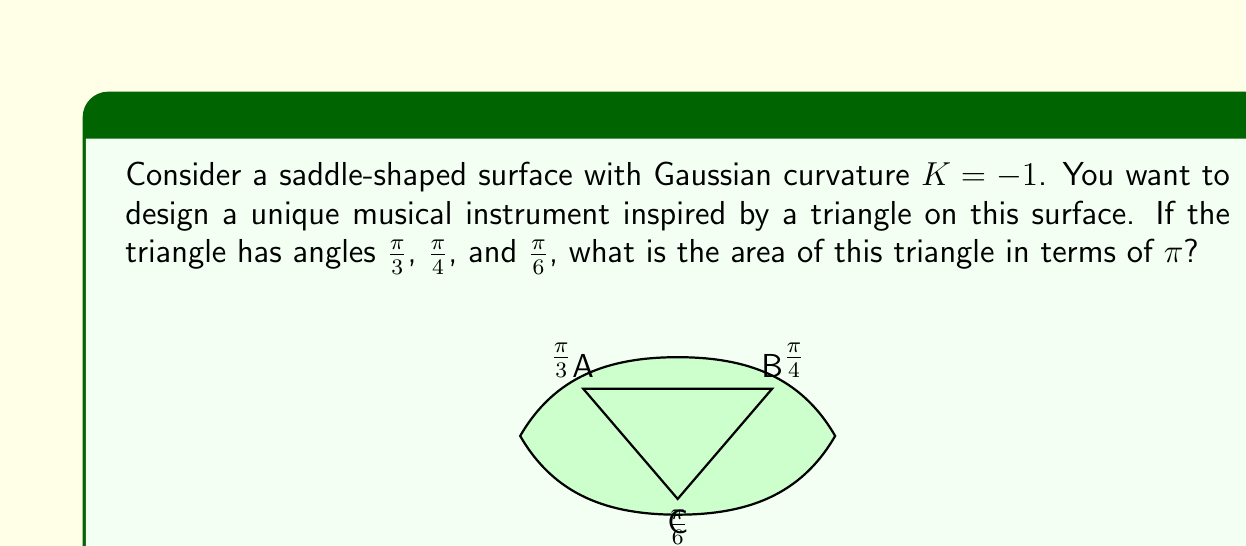Show me your answer to this math problem. Let's approach this step-by-step:

1) In Euclidean geometry, the sum of angles in a triangle is always $\pi$. However, on a saddle-shaped surface (hyperbolic geometry), this sum is less than $\pi$.

2) The Gauss-Bonnet theorem relates the geometry of a surface to its topology. For a triangle on a surface with Gaussian curvature $K$, the theorem states:

   $$A + \alpha + \beta + \gamma = \pi - K A$$

   where $A$ is the area of the triangle, and $\alpha$, $\beta$, and $\gamma$ are the angles of the triangle.

3) We're given that $K = -1$, and the angles are $\frac{\pi}{3}$, $\frac{\pi}{4}$, and $\frac{\pi}{6}$. Let's substitute these into the formula:

   $$A + \frac{\pi}{3} + \frac{\pi}{4} + \frac{\pi}{6} = \pi - (-1)A$$

4) Simplify the left side:

   $$A + \frac{\pi}{3} + \frac{\pi}{4} + \frac{\pi}{6} = A + \frac{4\pi}{12} + \frac{3\pi}{12} + \frac{2\pi}{12} = A + \frac{9\pi}{12} = A + \frac{3\pi}{4}$$

5) Now our equation looks like:

   $$A + \frac{3\pi}{4} = \pi + A$$

6) Subtract $A$ from both sides:

   $$\frac{3\pi}{4} = \pi$$

7) Subtract $\frac{3\pi}{4}$ from both sides:

   $$0 = \frac{\pi}{4}$$

Therefore, the area of the triangle is $\frac{\pi}{4}$.
Answer: $\frac{\pi}{4}$ 